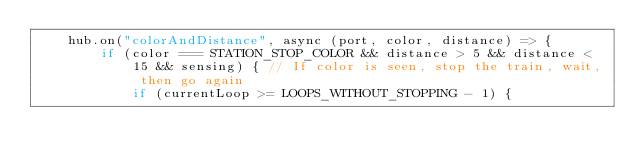Convert code to text. <code><loc_0><loc_0><loc_500><loc_500><_JavaScript_>    hub.on("colorAndDistance", async (port, color, distance) => {
        if (color === STATION_STOP_COLOR && distance > 5 && distance < 15 && sensing) { // If color is seen, stop the train, wait, then go again
            if (currentLoop >= LOOPS_WITHOUT_STOPPING - 1) {
</code> 